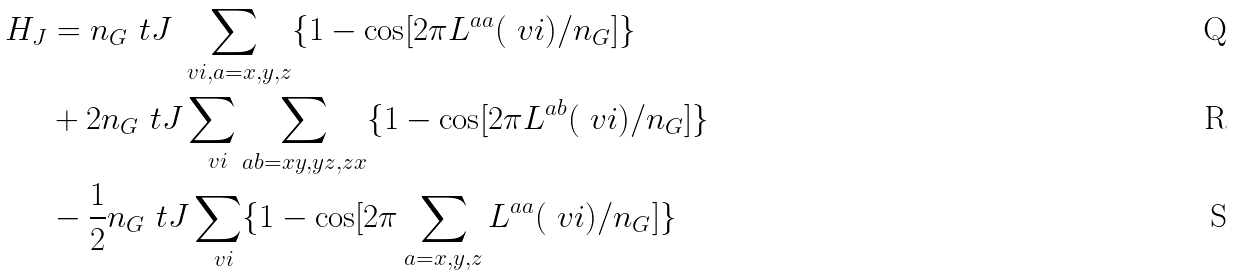Convert formula to latex. <formula><loc_0><loc_0><loc_500><loc_500>H _ { J } & = n _ { G } \ t J \sum _ { \ v i , a = x , y , z } \{ 1 - \cos [ 2 \pi L ^ { a a } ( \ v i ) / n _ { G } ] \} \\ & + 2 n _ { G } \ t J \sum _ { \ v i } \sum _ { a b = x y , y z , z x } \{ 1 - \cos [ 2 \pi L ^ { a b } ( \ v i ) / n _ { G } ] \} \\ & - \frac { 1 } { 2 } n _ { G } \ t J \sum _ { \ v i } \{ 1 - \cos [ 2 \pi \sum _ { a = x , y , z } L ^ { a a } ( \ v i ) / n _ { G } ] \}</formula> 